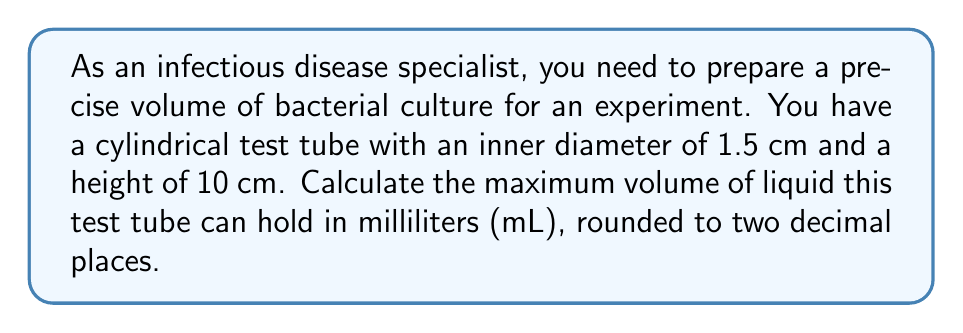Can you answer this question? To calculate the volume of a cylindrical test tube, we need to use the formula for the volume of a cylinder:

$$V = \pi r^2 h$$

Where:
$V$ = volume
$r$ = radius of the base
$h$ = height of the cylinder

Let's solve this step-by-step:

1. We're given the diameter, so we need to calculate the radius:
   $r = \frac{diameter}{2} = \frac{1.5 \text{ cm}}{2} = 0.75 \text{ cm}$

2. Now we can substitute the values into the formula:
   $$V = \pi (0.75 \text{ cm})^2 (10 \text{ cm})$$

3. Calculate:
   $$V = \pi (0.5625 \text{ cm}^2) (10 \text{ cm})$$
   $$V = 5.625\pi \text{ cm}^3$$

4. Evaluate $\pi$ and calculate:
   $$V \approx 17.6715 \text{ cm}^3$$

5. Convert cubic centimeters to milliliters:
   1 cm³ = 1 mL, so the volume is already in mL.

6. Round to two decimal places:
   $$V \approx 17.67 \text{ mL}$$

This is the maximum volume the test tube can hold, ensuring precise measurements for your bacterial culture experiment.
Answer: 17.67 mL 